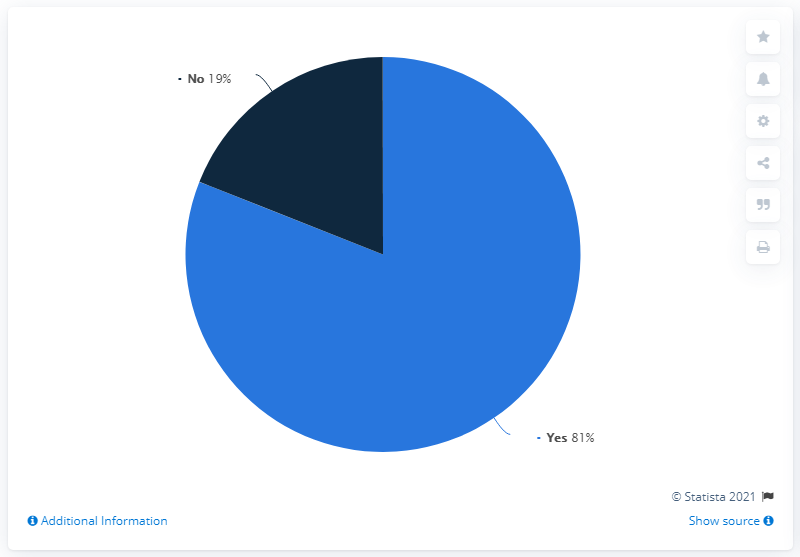Specify some key components in this picture. The options available are either 'Yes' or 'No.' The ratio between "yes" and "no" is approximately 4.263157895... 